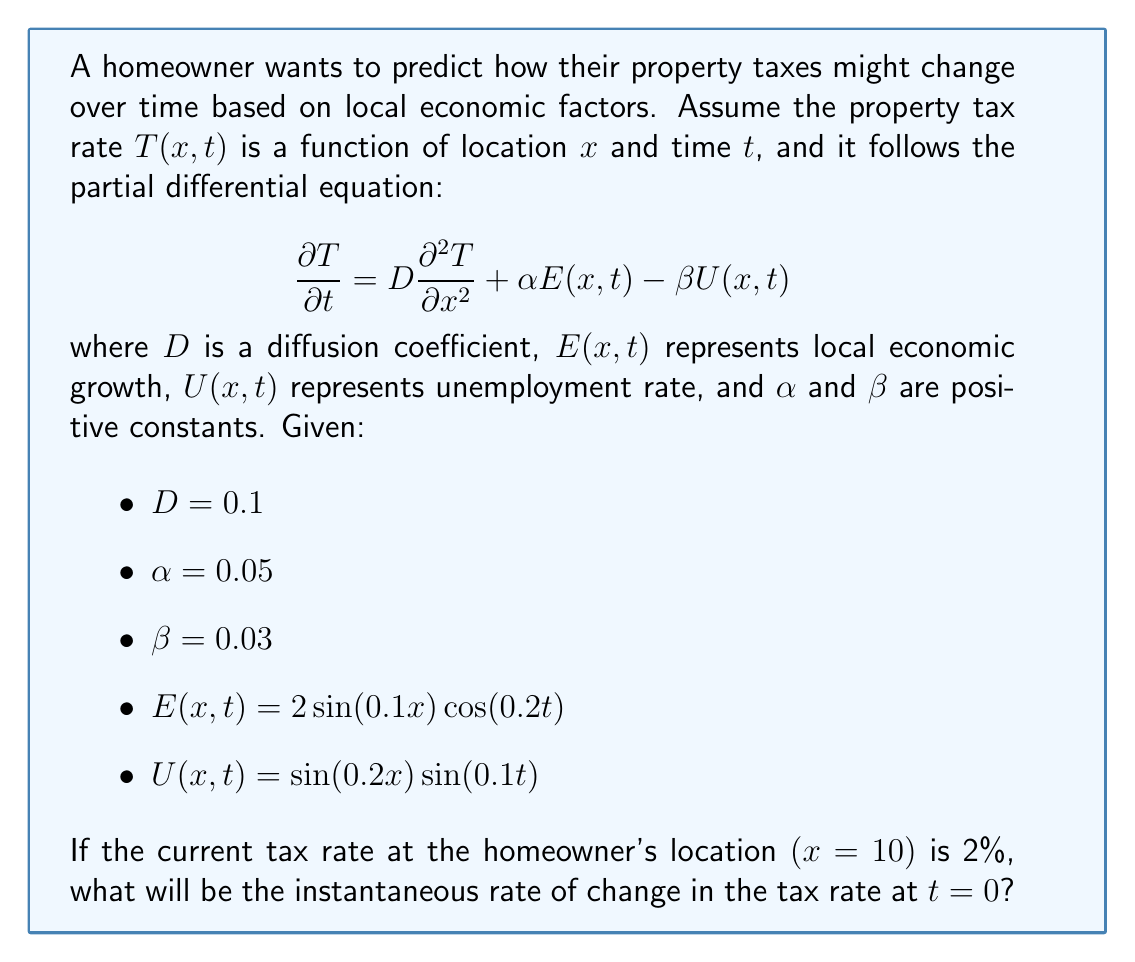Give your solution to this math problem. To solve this problem, we need to evaluate the partial differential equation at the given point and time. Let's break it down step-by-step:

1) The PDE is given as:

   $$\frac{\partial T}{\partial t} = D\frac{\partial^2 T}{\partial x^2} + \alpha E(x,t) - \beta U(x,t)$$

2) We're asked to find $\frac{\partial T}{\partial t}$ at $x=10$ and $t=0$. We don't have information about $\frac{\partial^2 T}{\partial x^2}$, but we can calculate the other terms.

3) Let's evaluate $E(x,t)$ at $x=10$ and $t=0$:
   
   $E(10,0) = 2\sin(0.1 \cdot 10)\cos(0.2 \cdot 0) = 2\sin(1) \cdot 1 \approx 1.6829$

4) Now, let's evaluate $U(x,t)$ at $x=10$ and $t=0$:
   
   $U(10,0) = \sin(0.2 \cdot 10)\sin(0.1 \cdot 0) = \sin(2) \cdot 0 = 0$

5) Substituting these values into the PDE:

   $$\frac{\partial T}{\partial t} = 0.1\frac{\partial^2 T}{\partial x^2} + 0.05 \cdot 1.6829 - 0.03 \cdot 0$$

6) Simplifying:

   $$\frac{\partial T}{\partial t} = 0.1\frac{\partial^2 T}{\partial x^2} + 0.084145$$

7) We don't have information about $\frac{\partial^2 T}{\partial x^2}$, but we know it represents the curvature of the tax rate with respect to location. In the absence of this information, we can assume it's zero for a first-order approximation.

8) With this assumption:

   $$\frac{\partial T}{\partial t} \approx 0.084145$$

This means the tax rate is increasing at approximately 0.084145 percentage points per unit time at the given location and time.
Answer: The instantaneous rate of change in the tax rate at the homeowner's location $(x=10)$ at $t=0$ is approximately 0.084145 percentage points per unit time. 